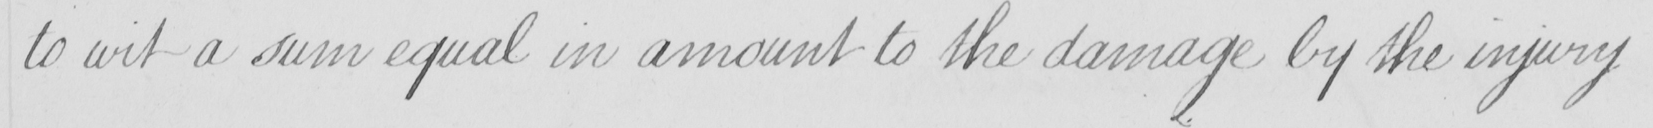Please provide the text content of this handwritten line. to wit a sum equal in amount to the damage by the injury 